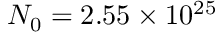<formula> <loc_0><loc_0><loc_500><loc_500>N _ { 0 } = 2 . 5 5 \times 1 0 ^ { 2 5 }</formula> 